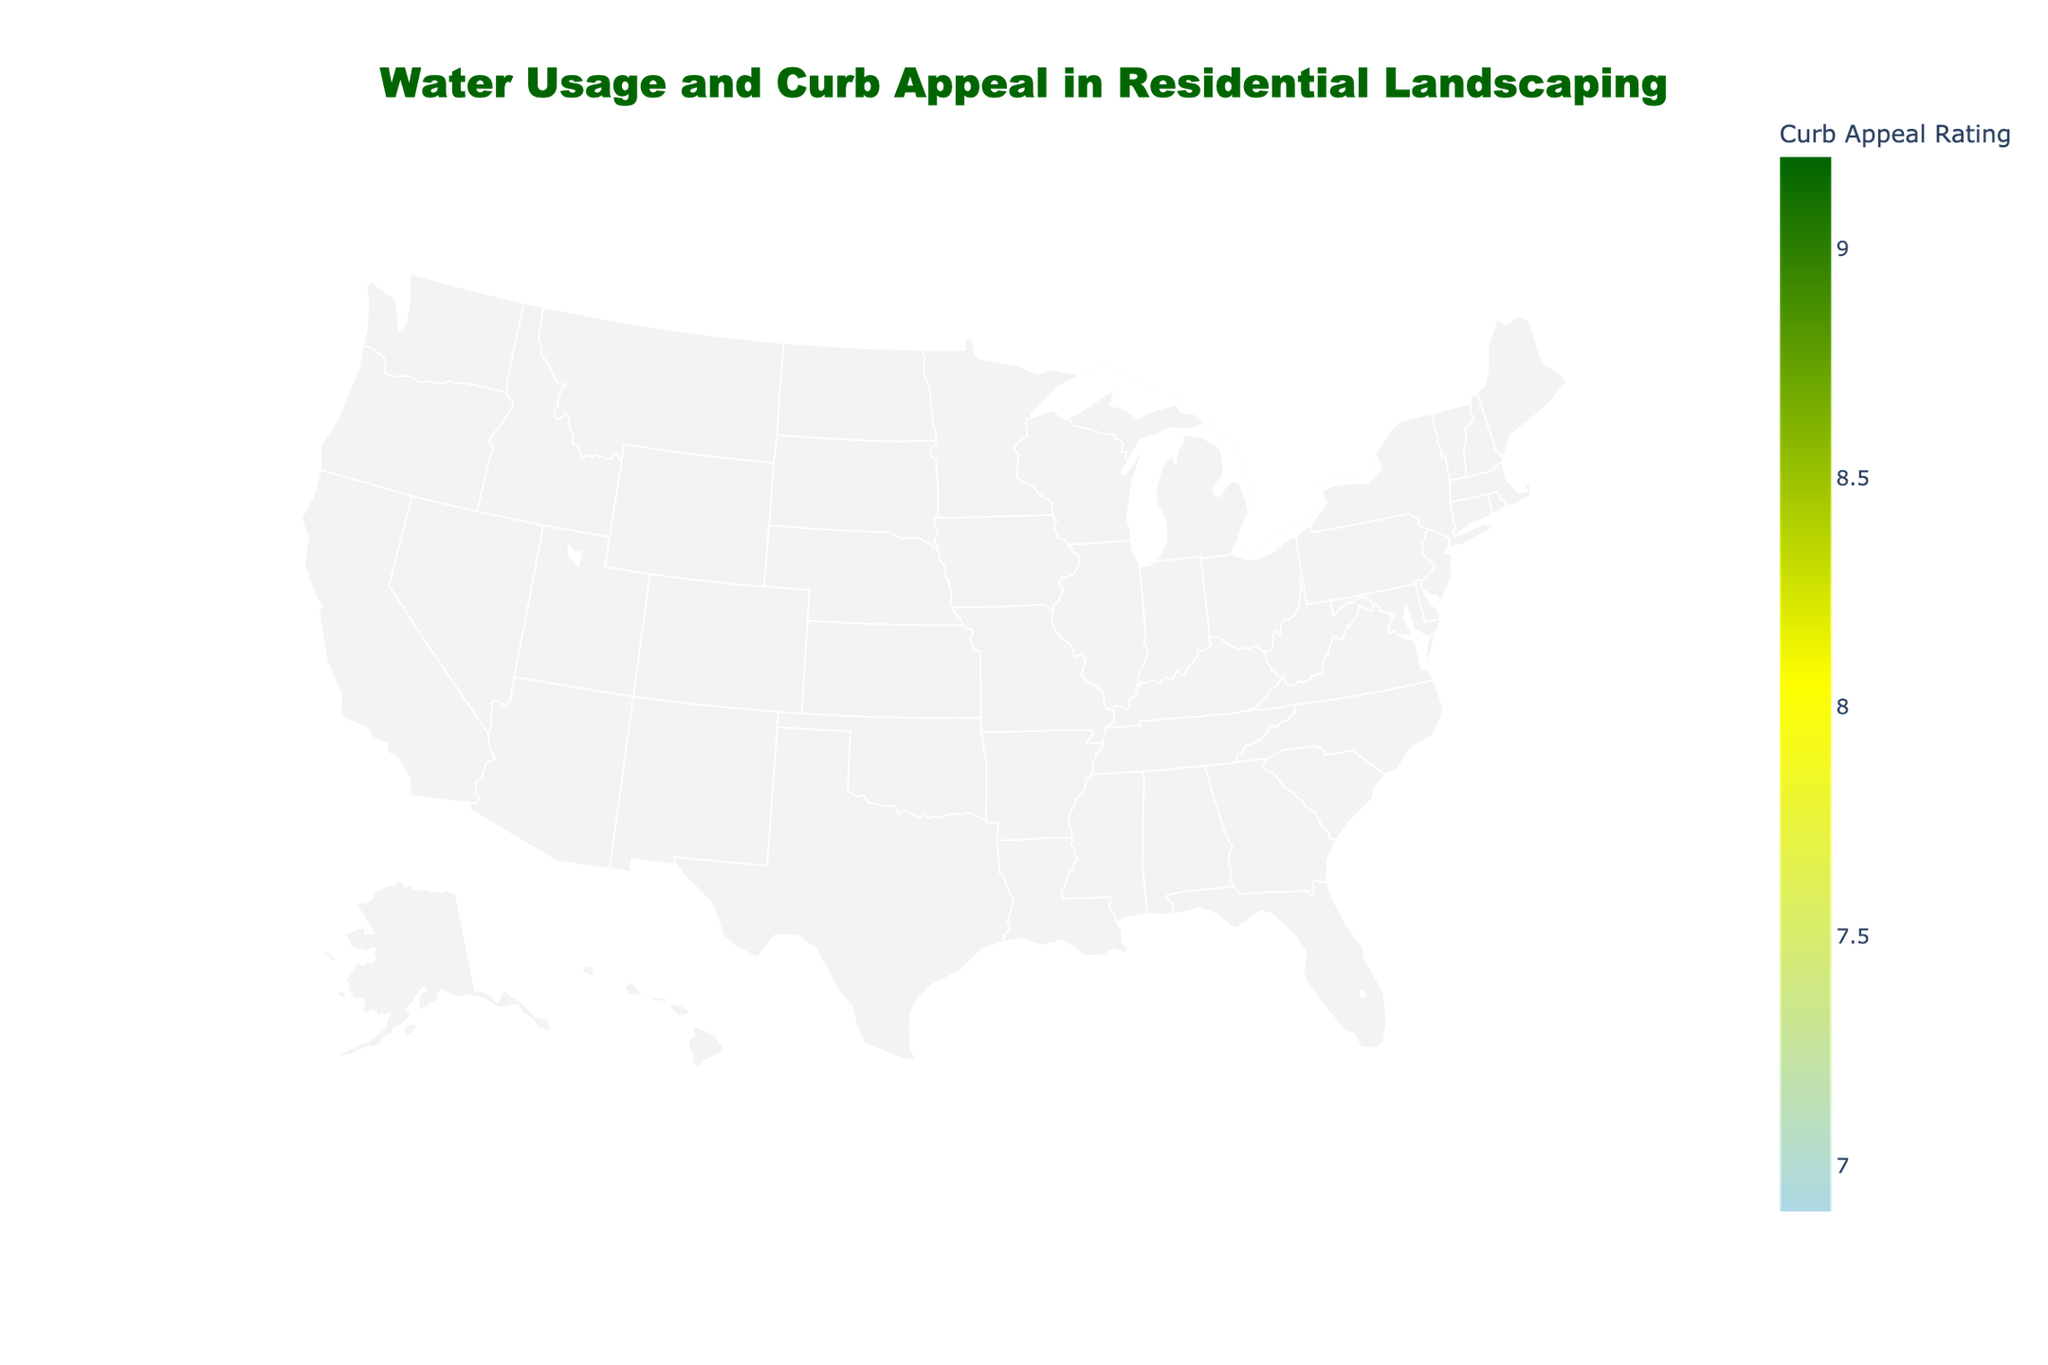what's the title of the figure? The title of a figure is usually prominently displayed, often at the top. The title of this figure is "Water Usage and Curb Appeal in Residential Landscaping."
Answer: Water Usage and Curb Appeal in Residential Landscaping How many neighborhoods are shown? The number of neighborhoods is typically indicated by the number of distinct data points. In this case, each zip code represents a different neighborhood. There are 10 neighborhoods as per the provided data.
Answer: 10 Which neighborhood has the highest curb appeal rating? The curb appeal rating is represented by color in the scatter plot. By scanning for the neighborhood with the darkest shade of green (highest rating), it's evident that Beverly Hills (zip code 90210) has the highest curb appeal rating of 9.2.
Answer: Beverly Hills What is the average daily water usage for South Beach? The water usage data for each neighborhood is given in gallons/day. For South Beach (zip code 33139), the value is 280 gallons/day.
Answer: 280 gallons/day Which neighborhood has the lowest water usage and what is its landscaping type? By identifying the smallest data point on the plot (smallest circle), we see that Tribeca (zip code 10007) has the lowest water usage at 150 gallons/day. Its dominant landscaping type is Rooftop Gardens.
Answer: Tribeca, Rooftop Gardens How does the average daily water usage of Cherry Creek compare to that of Lincoln Park? By looking at their respective water usage values: Cherry Creek has 205 gallons/day and Lincoln Park has 190 gallons/day. To compare, 205 - 190 = 15 gallons/day more in Cherry Creek.
Answer: 15 gallons/day more in Cherry Creek What is the median curb appeal rating among the neighborhoods? To find the median, we need to list all curb appeal ratings: 9.2, 8.8, 8.5, 8.1, 8.0, 7.8, 7.6, 7.5, 7.3, 6.9. The median value is the middle of this sorted list. The middle values are 8.0 and 8.1, so the median is (8.0 + 8.1)/2 = 8.05.
Answer: 8.05 Which neighborhood uses more water per day, Marina District or Medina? Checking Marina District (zip code 94123) and Medina (zip code 98004) for their water usage: Marina District uses 210 gallons/day and Medina uses 240 gallons/day. Thus, Medina uses more water per day.
Answer: Medina What is the most common landscaping type among these neighborhoods? The landscaping types need to be counted for occurrence: 
- Lush Gardens 
- Drought-Tolerant 
- Tropical Palms 
- Urban Green 
- Northwest Native 
- Xeriscaping 
- Rooftop Gardens 
- Mediterranean 
- Classic New England 
- Rocky Mountain. None of the types repeat in the data provided. Therefore, there is no most common type.
Answer: No most common type 